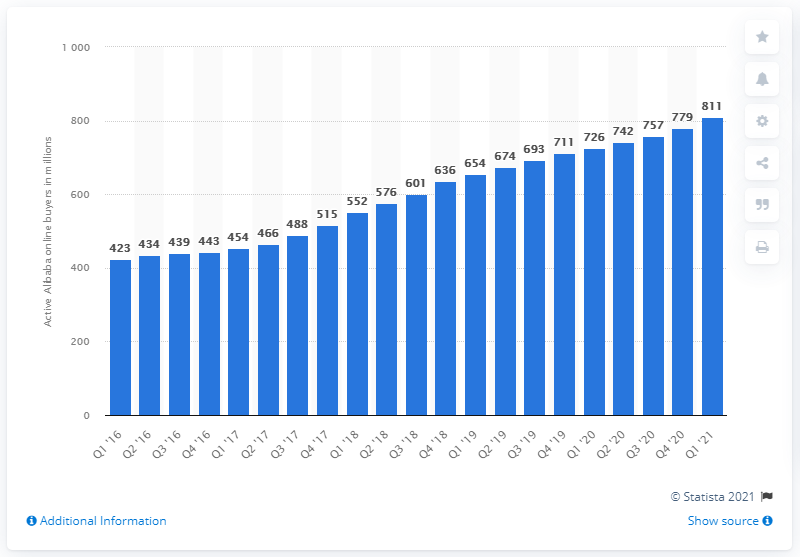Give some essential details in this illustration. In the last quarter of 2020, there were 779 active consumers on Alibaba's online shopping properties in China. At the end of March, there were 811 active consumers on Alibaba's online shopping properties in China. 